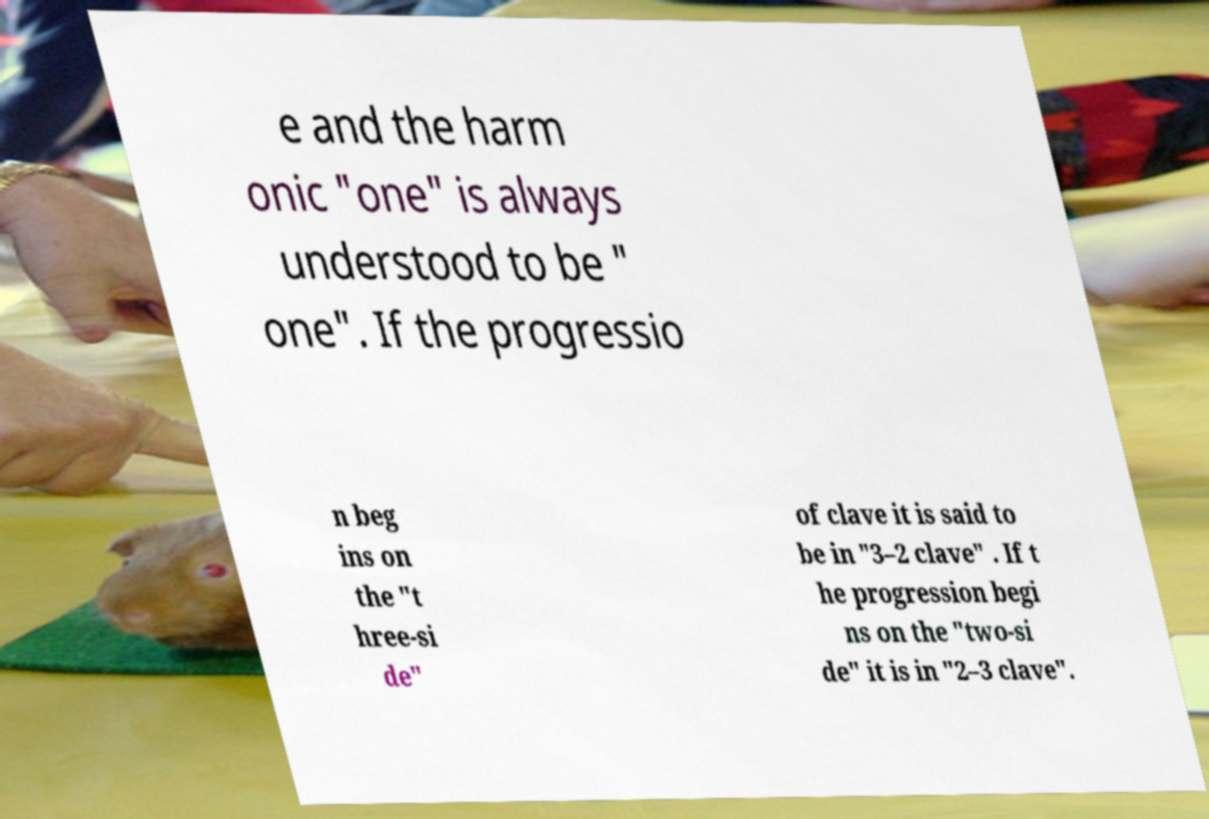Please identify and transcribe the text found in this image. e and the harm onic "one" is always understood to be " one". If the progressio n beg ins on the "t hree-si de" of clave it is said to be in "3–2 clave" . If t he progression begi ns on the "two-si de" it is in "2–3 clave". 